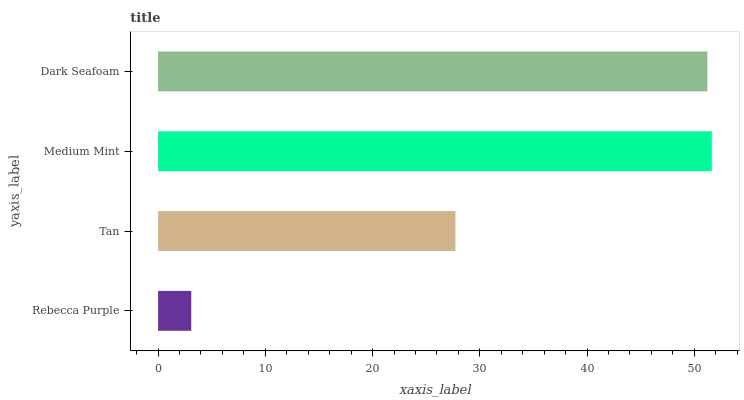Is Rebecca Purple the minimum?
Answer yes or no. Yes. Is Medium Mint the maximum?
Answer yes or no. Yes. Is Tan the minimum?
Answer yes or no. No. Is Tan the maximum?
Answer yes or no. No. Is Tan greater than Rebecca Purple?
Answer yes or no. Yes. Is Rebecca Purple less than Tan?
Answer yes or no. Yes. Is Rebecca Purple greater than Tan?
Answer yes or no. No. Is Tan less than Rebecca Purple?
Answer yes or no. No. Is Dark Seafoam the high median?
Answer yes or no. Yes. Is Tan the low median?
Answer yes or no. Yes. Is Rebecca Purple the high median?
Answer yes or no. No. Is Medium Mint the low median?
Answer yes or no. No. 